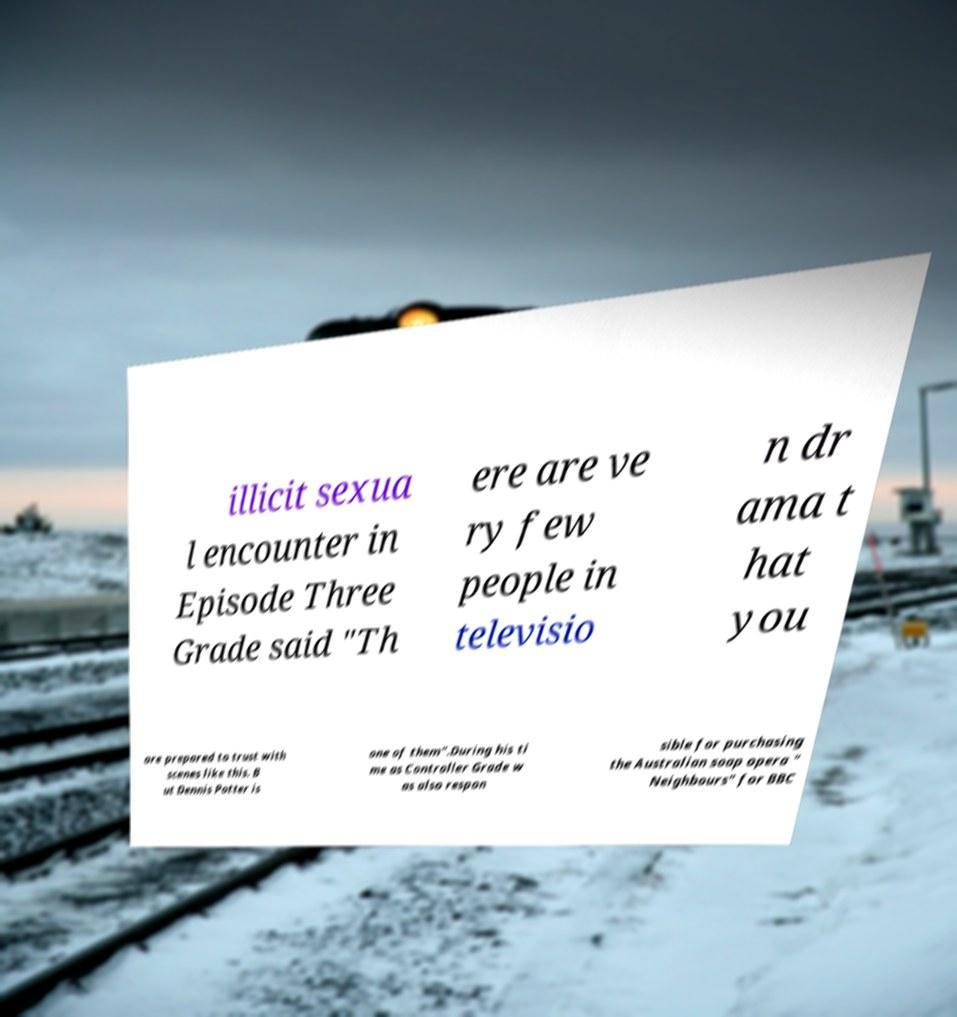For documentation purposes, I need the text within this image transcribed. Could you provide that? illicit sexua l encounter in Episode Three Grade said "Th ere are ve ry few people in televisio n dr ama t hat you are prepared to trust with scenes like this. B ut Dennis Potter is one of them".During his ti me as Controller Grade w as also respon sible for purchasing the Australian soap opera " Neighbours" for BBC 